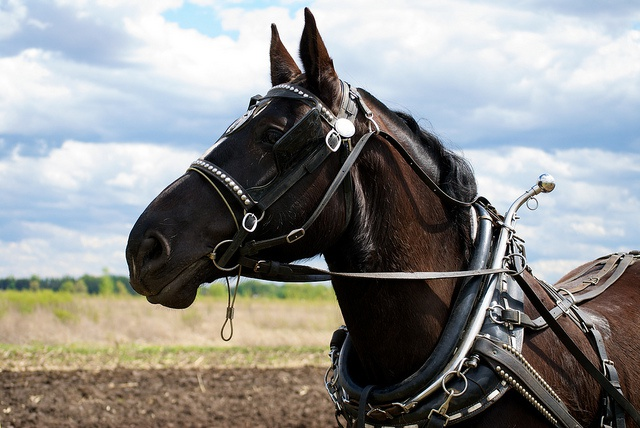Describe the objects in this image and their specific colors. I can see a horse in lightblue, black, gray, maroon, and darkgray tones in this image. 